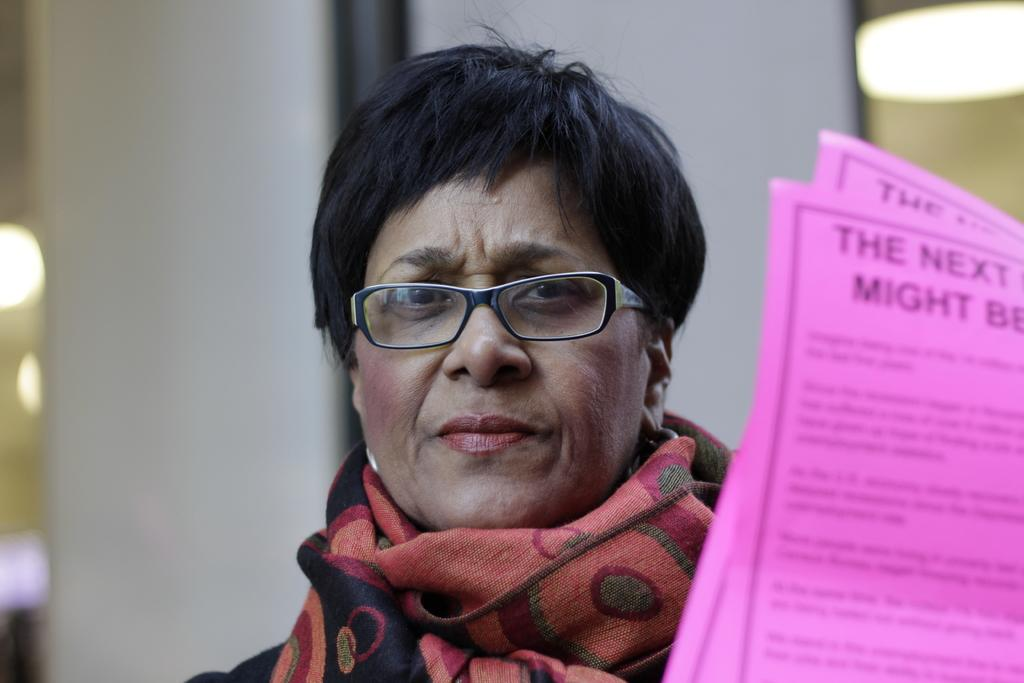What is the person in the image wearing on their face? The person in the image is wearing spectacles. What type of clothing is the person wearing around their neck? The person is wearing a scarf. What direction is the person looking in the image? The person is looking forward. How would you describe the background of the image? The background of the image is blurred. What can be seen on the right side of the image? There are two pink papers on the right side of the image. What type of impulse can be seen affecting the person in the image? There is no impulse affecting the person in the image; they are simply looking forward. Can you tell me how many needles are present in the image? There are no needles present in the image. 